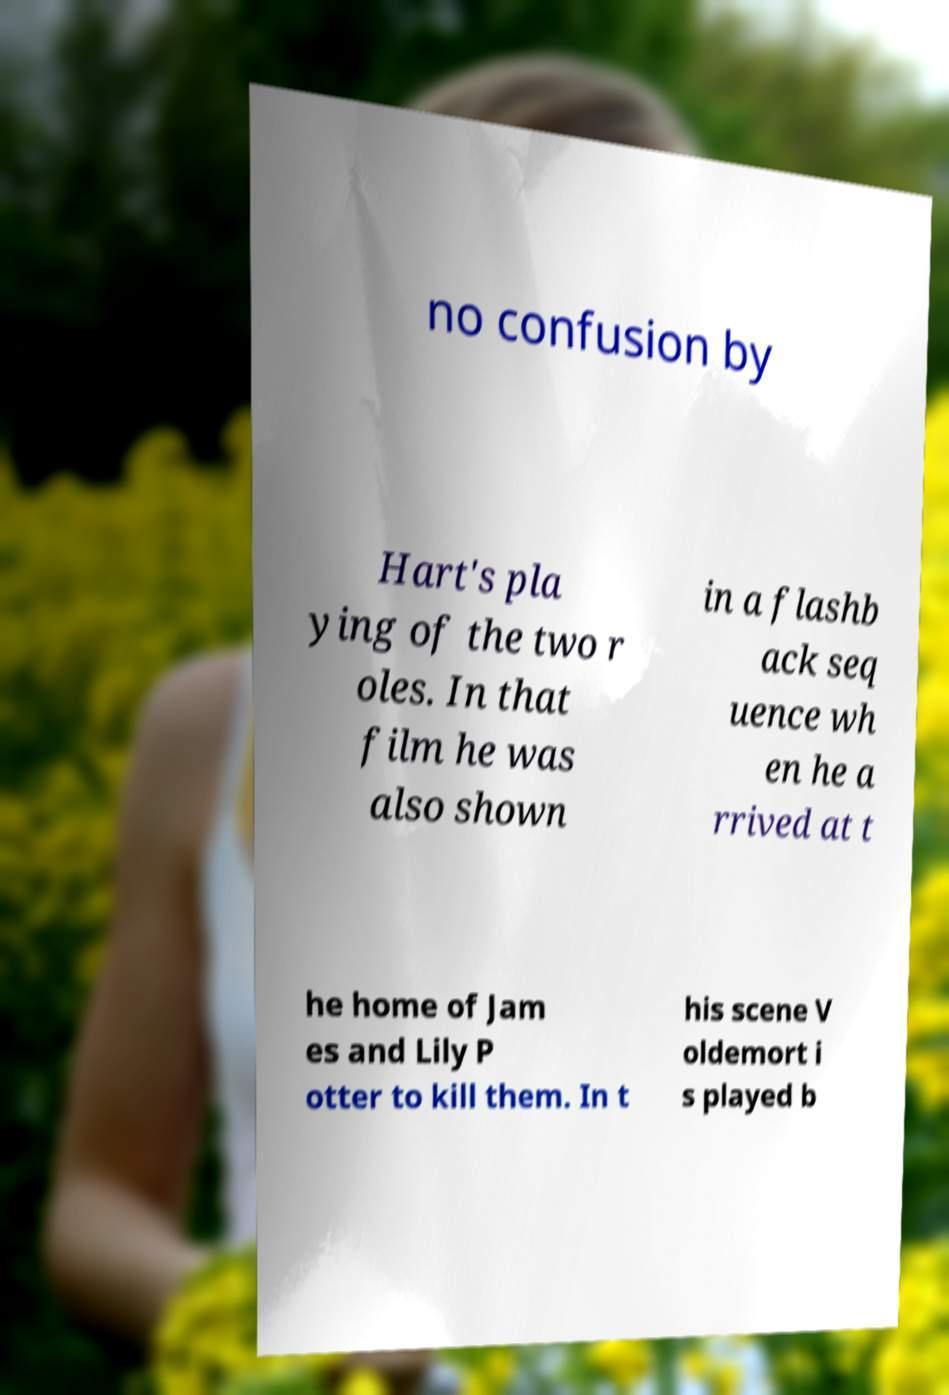Could you extract and type out the text from this image? no confusion by Hart's pla ying of the two r oles. In that film he was also shown in a flashb ack seq uence wh en he a rrived at t he home of Jam es and Lily P otter to kill them. In t his scene V oldemort i s played b 